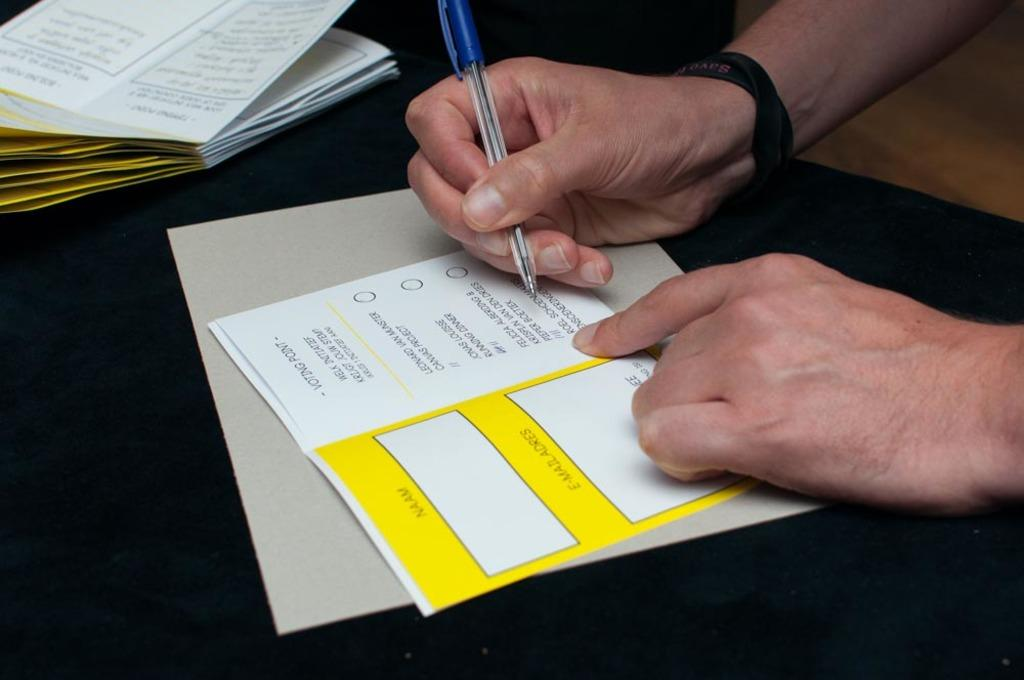<image>
Present a compact description of the photo's key features. A man fills out a voting point form using a pen. 